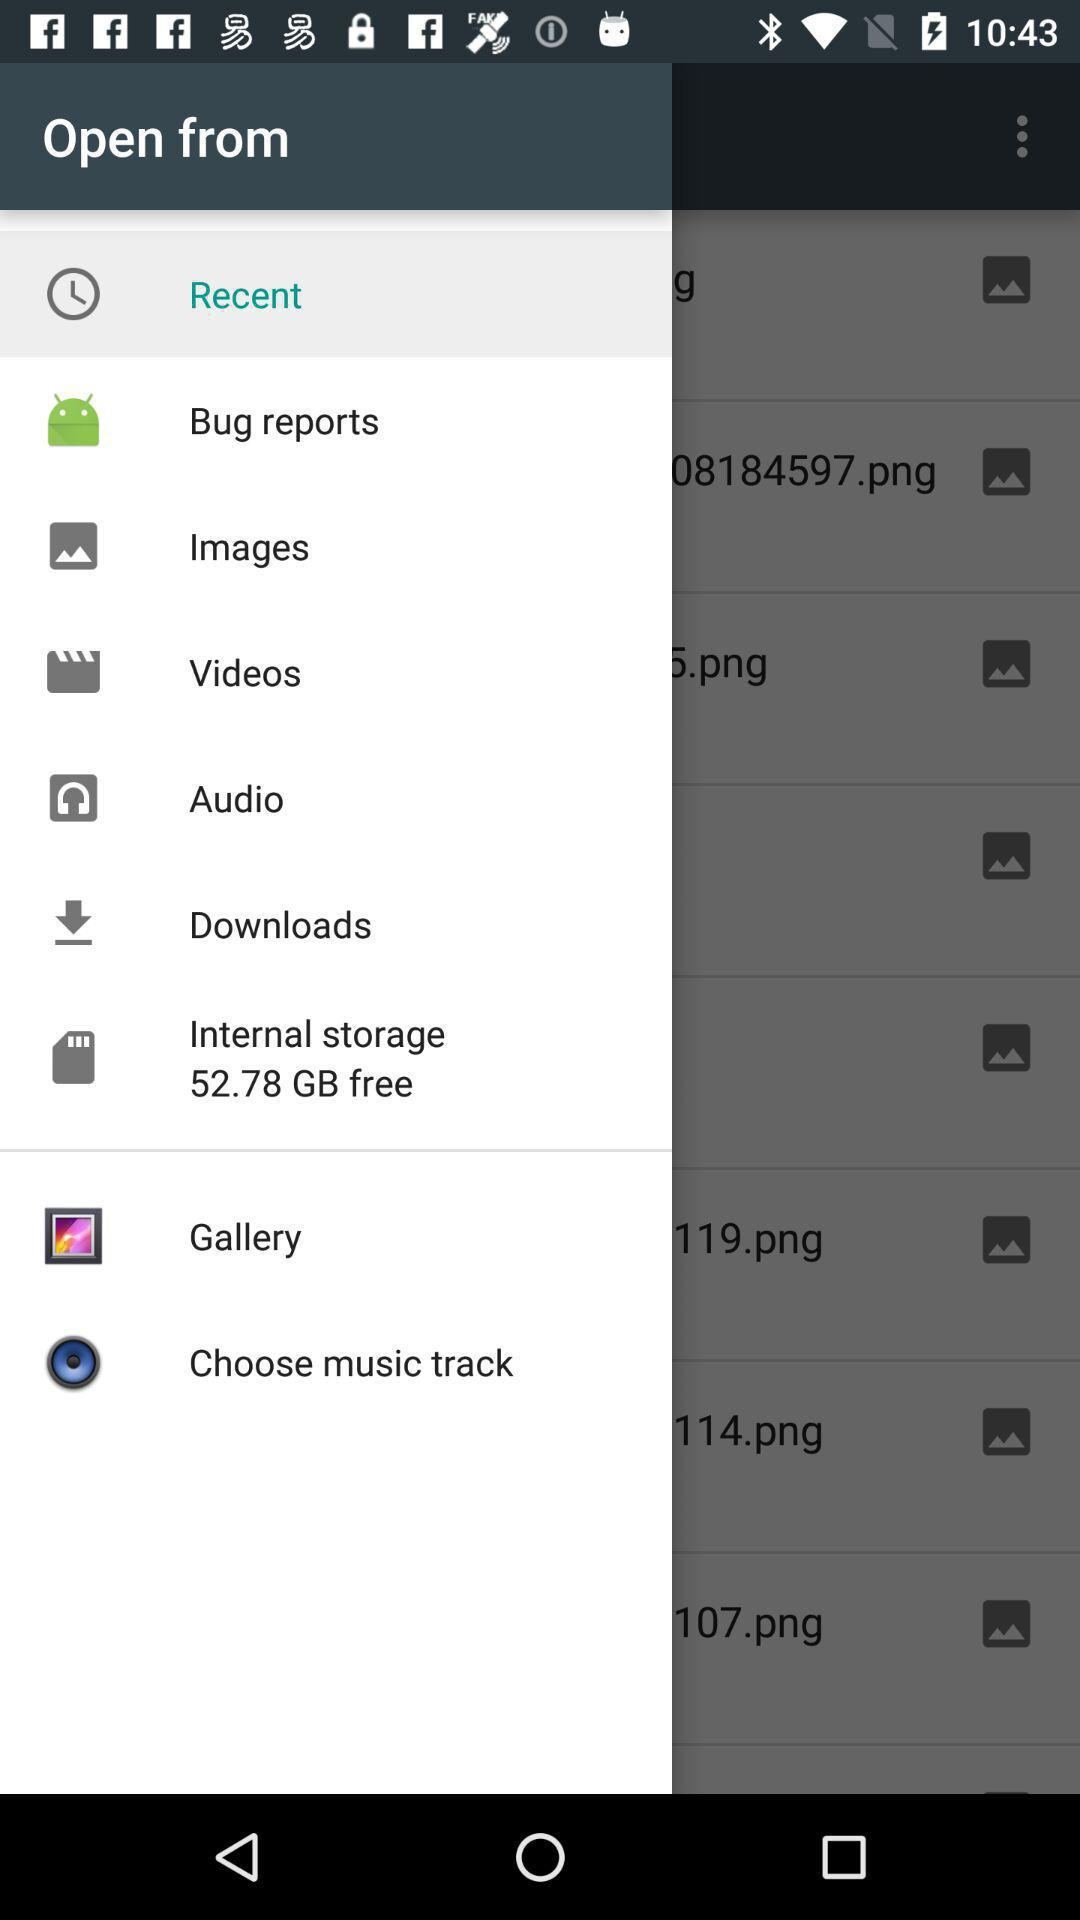How much free space is available in internal storage? The free space available in internal storage is 52.78 GB. 